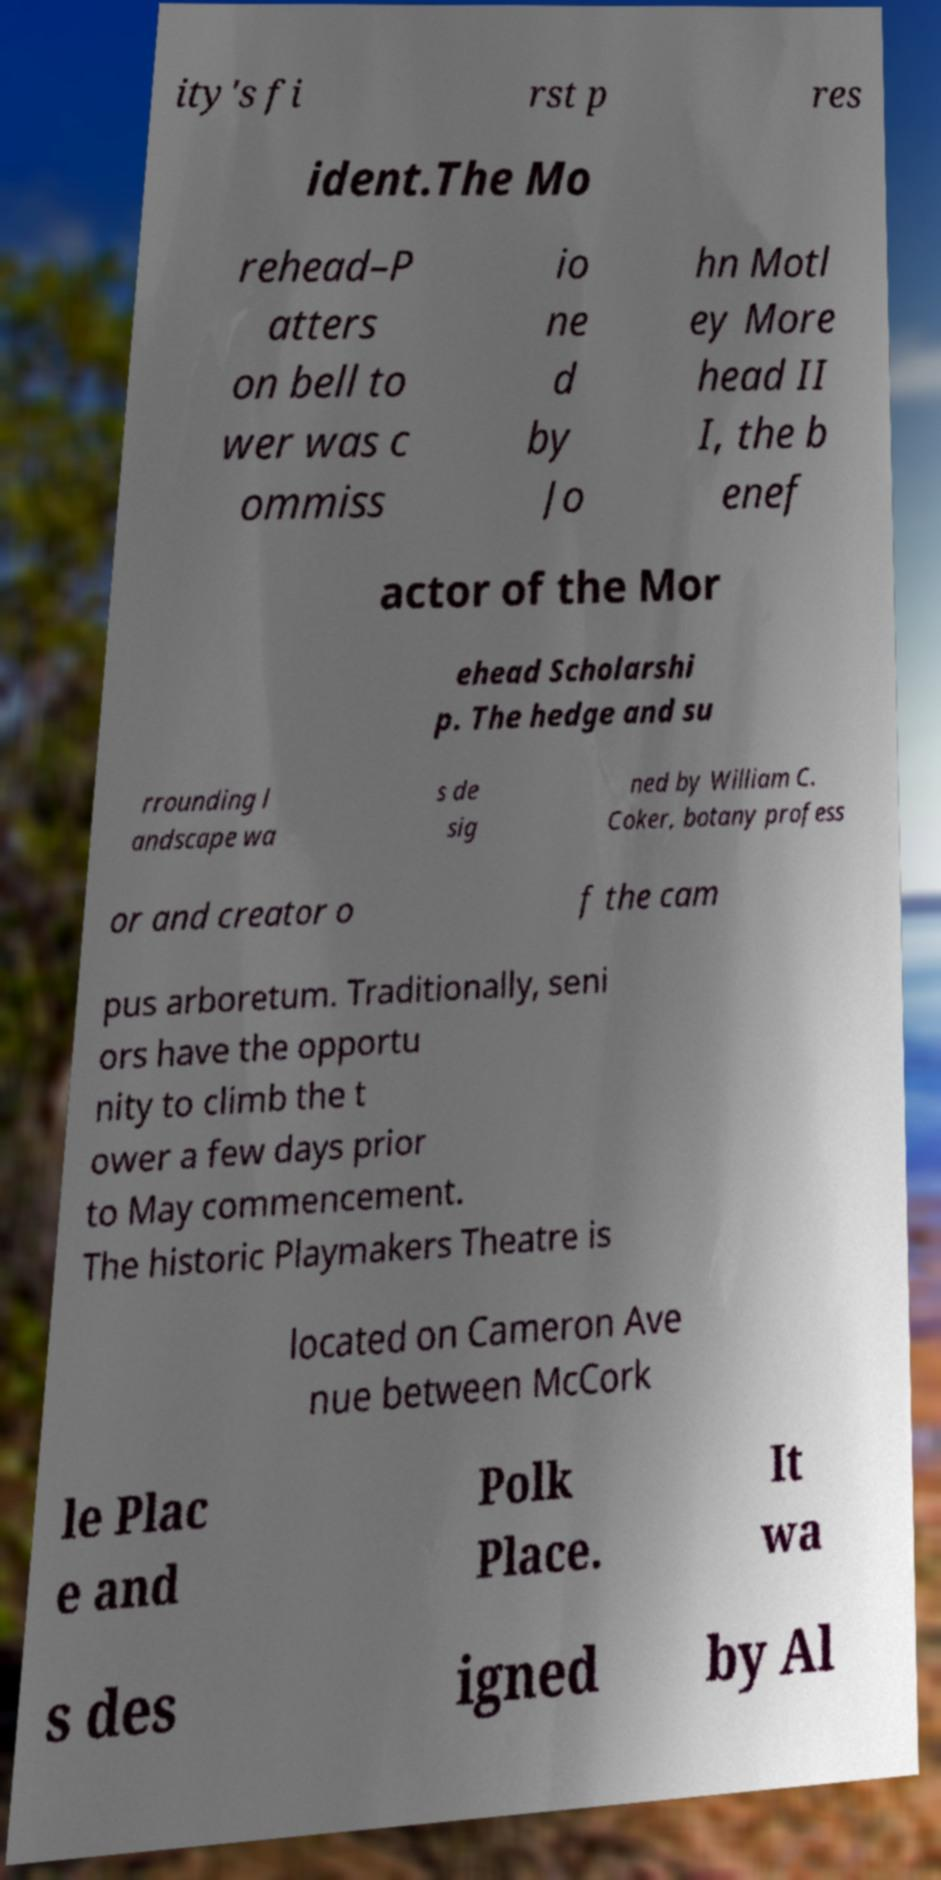Could you assist in decoding the text presented in this image and type it out clearly? ity's fi rst p res ident.The Mo rehead–P atters on bell to wer was c ommiss io ne d by Jo hn Motl ey More head II I, the b enef actor of the Mor ehead Scholarshi p. The hedge and su rrounding l andscape wa s de sig ned by William C. Coker, botany profess or and creator o f the cam pus arboretum. Traditionally, seni ors have the opportu nity to climb the t ower a few days prior to May commencement. The historic Playmakers Theatre is located on Cameron Ave nue between McCork le Plac e and Polk Place. It wa s des igned by Al 